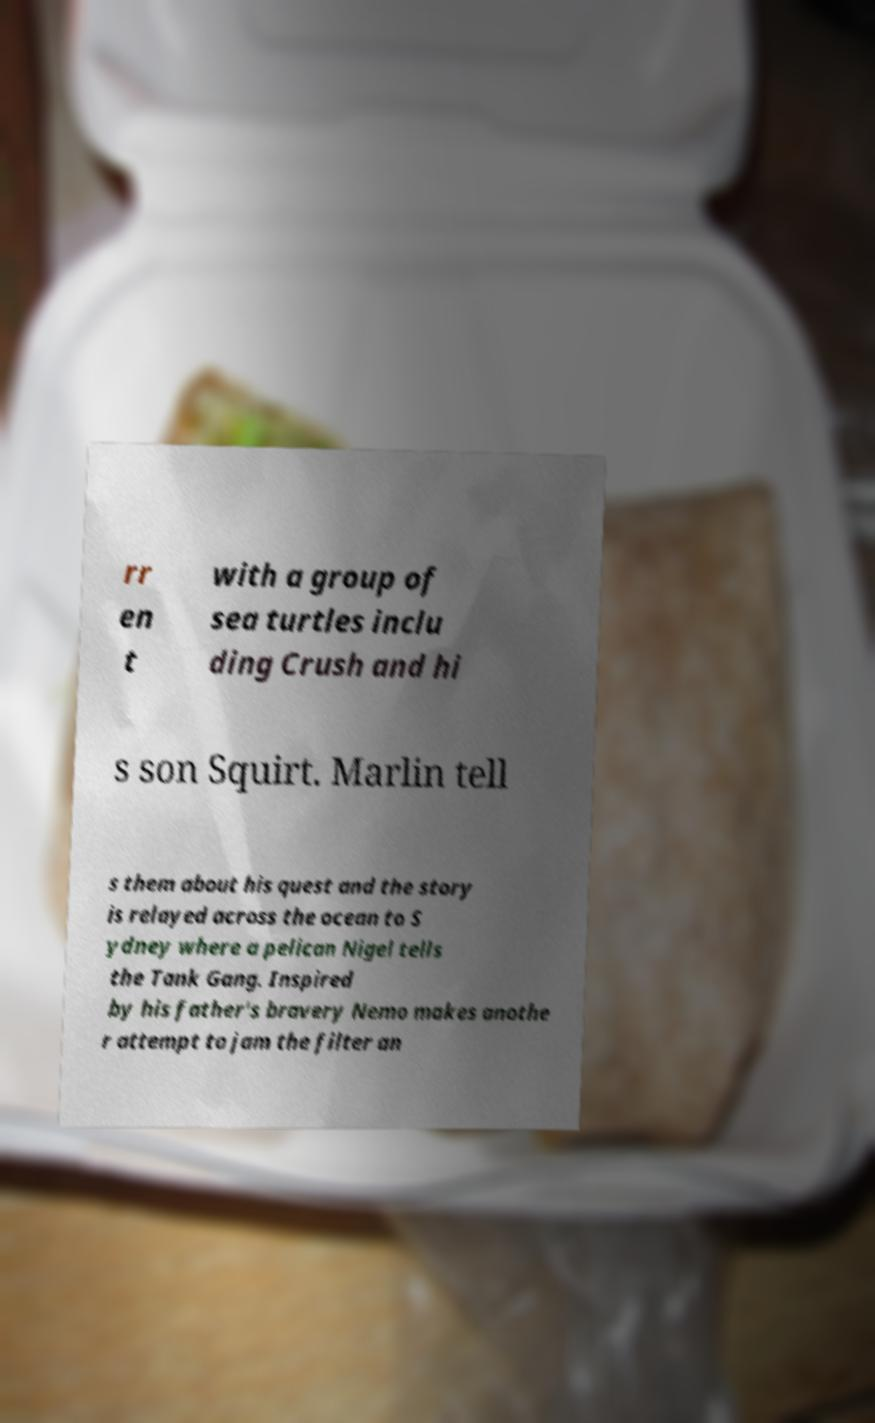Can you accurately transcribe the text from the provided image for me? rr en t with a group of sea turtles inclu ding Crush and hi s son Squirt. Marlin tell s them about his quest and the story is relayed across the ocean to S ydney where a pelican Nigel tells the Tank Gang. Inspired by his father's bravery Nemo makes anothe r attempt to jam the filter an 